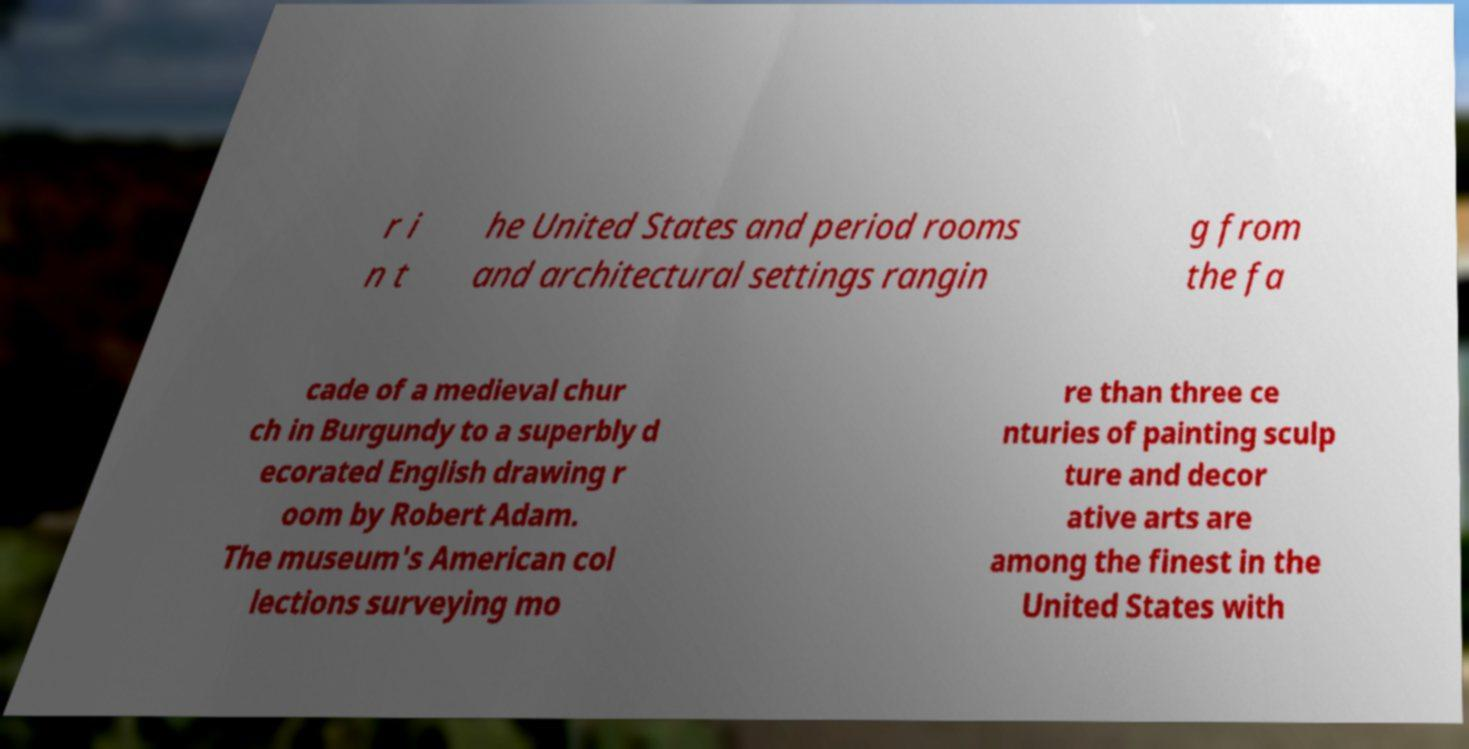Could you assist in decoding the text presented in this image and type it out clearly? r i n t he United States and period rooms and architectural settings rangin g from the fa cade of a medieval chur ch in Burgundy to a superbly d ecorated English drawing r oom by Robert Adam. The museum's American col lections surveying mo re than three ce nturies of painting sculp ture and decor ative arts are among the finest in the United States with 